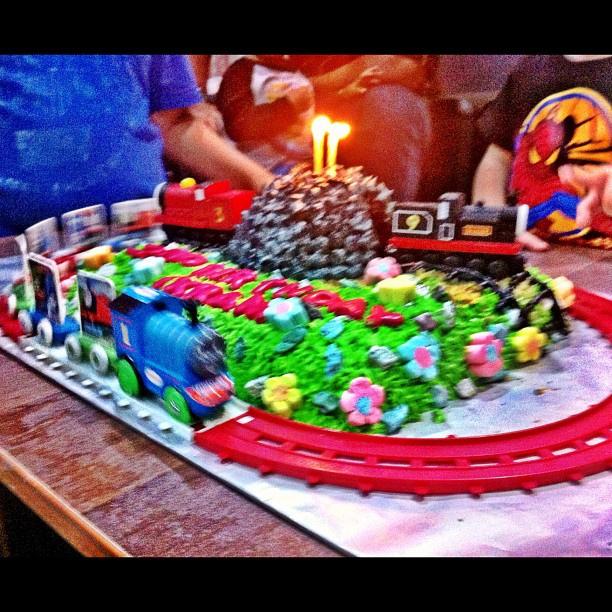What is going around the cake?
Concise answer only. Train. What marvel comic character is in this picture?
Give a very brief answer. Spiderman. Is this a cake?
Be succinct. Yes. 